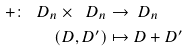Convert formula to latex. <formula><loc_0><loc_0><loc_500><loc_500>+ \colon \ D _ { n } \times \ D _ { n } & \to \ D _ { n } \\ ( D , D ^ { \prime } ) & \mapsto D + D ^ { \prime }</formula> 